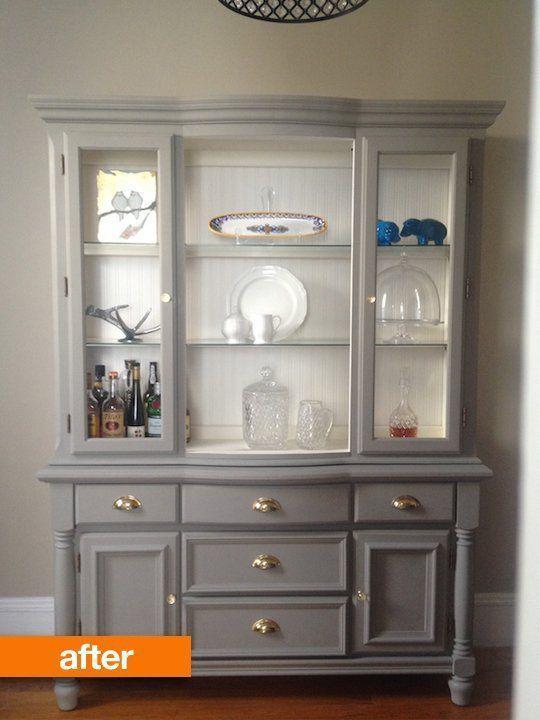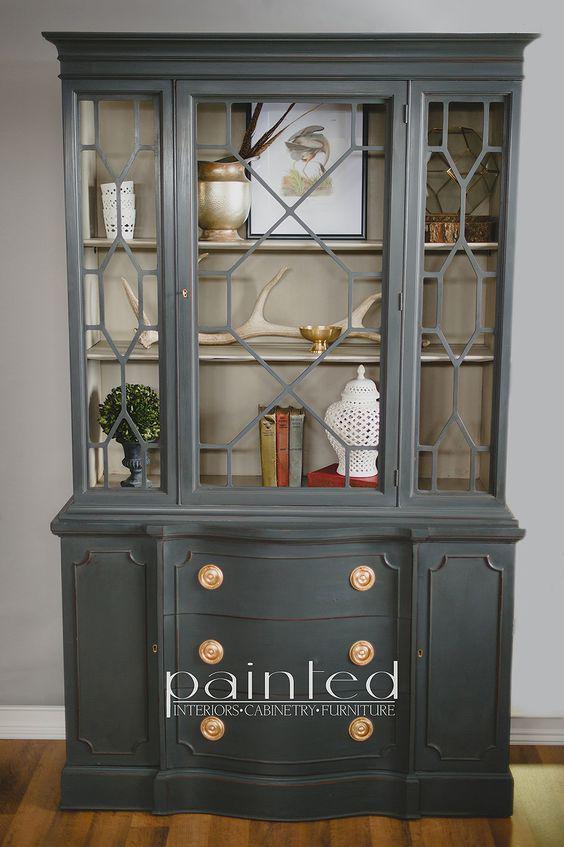The first image is the image on the left, the second image is the image on the right. Assess this claim about the two images: "A blue hutch in one image has four glass doors and four lower panel doors, and is wider than a white hutch with glass doors in the second image.". Correct or not? Answer yes or no. No. The first image is the image on the left, the second image is the image on the right. Examine the images to the left and right. Is the description "one of the hutch is white" accurate? Answer yes or no. No. The first image is the image on the left, the second image is the image on the right. Given the left and right images, does the statement "One cabinet has a curved top with a fleur-de-lis design, and scrollwork at the footed base." hold true? Answer yes or no. No. 